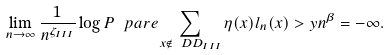<formula> <loc_0><loc_0><loc_500><loc_500>\lim _ { n \to \infty } \frac { 1 } { n ^ { \zeta _ { I \, I \, I } } } \log P \ p a r e { \sum _ { x \not \in \ D D _ { I \, I \, I } } \eta ( x ) l _ { n } ( x ) > y n ^ { \beta } } = - \infty .</formula> 